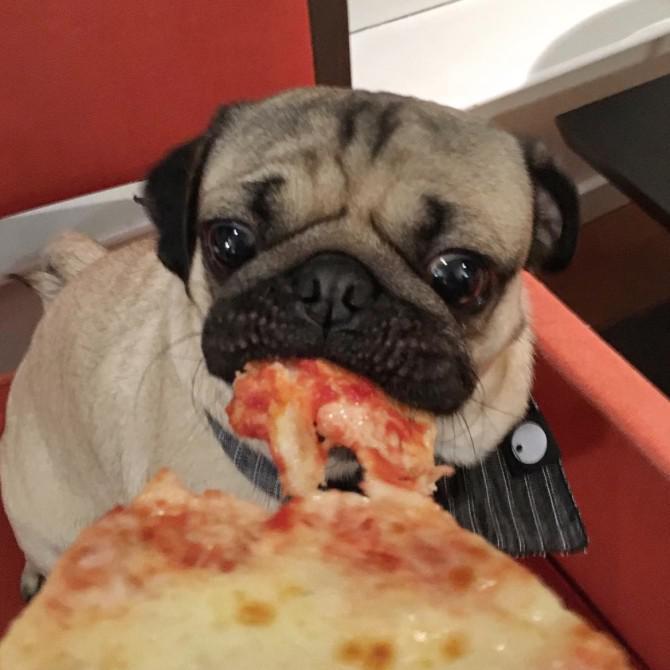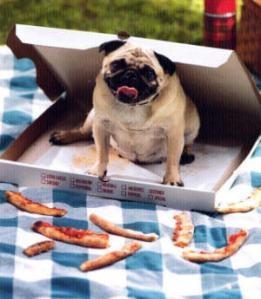The first image is the image on the left, the second image is the image on the right. Assess this claim about the two images: "A dog is eating a plain cheese pizza in at least one of the images.". Correct or not? Answer yes or no. Yes. The first image is the image on the left, the second image is the image on the right. For the images shown, is this caption "A chubby beige pug is sitting in a container in one image, and the other image shows a pug with orange food in front of its mouth." true? Answer yes or no. Yes. 